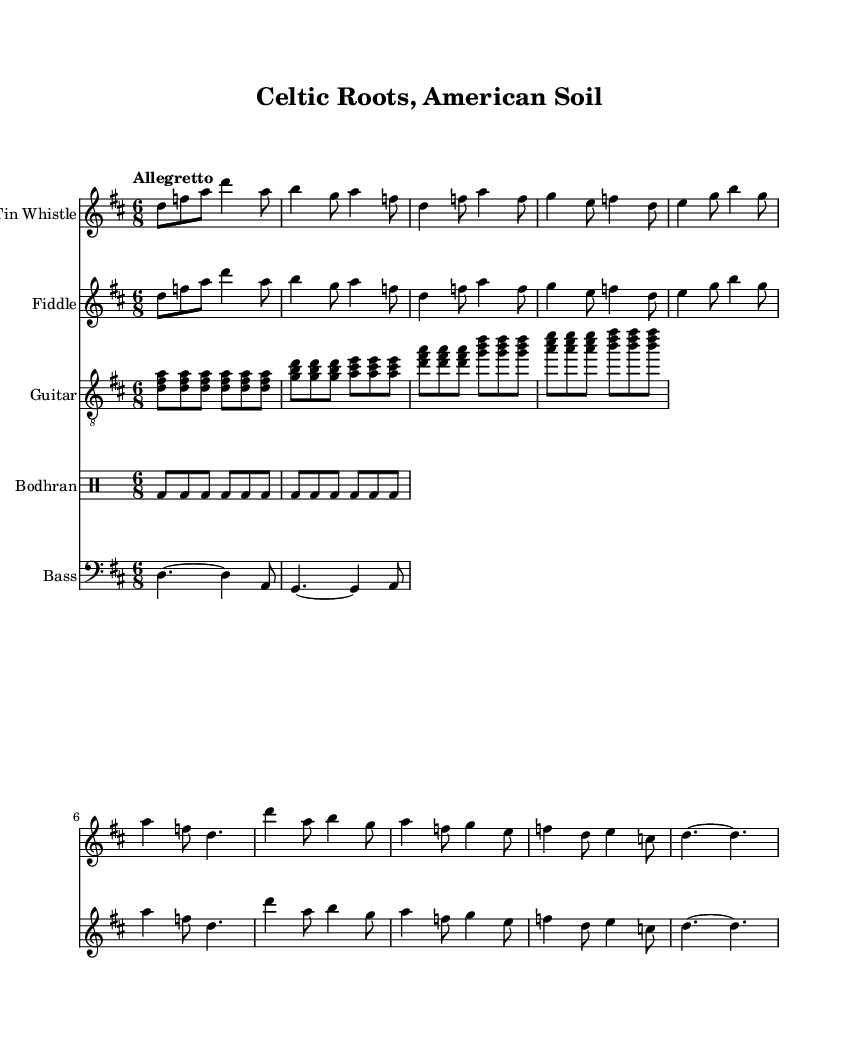What is the key signature of this music? The key signature is D major, which has two sharps (F# and C#). This is derived from the global settings at the beginning of the sheet music where it indicates the key is set to D major.
Answer: D major What is the time signature of the piece? The time signature is 6/8, indicating that there are six beats in a measure and the eighth note gets one beat. This is stated in the global settings within the sheet music, specifying the time signature.
Answer: 6/8 What tempo marking is used for this music? The tempo marking is "Allegretto," which is a moderately fast tempo. This is mentioned at the beginning of the score under global settings.
Answer: Allegretto How many sections are there in the music? There are two main sections identified: Verse and Chorus. The sheet music layout divides the music into these segments clearly, with each labeled accordingly in the annotations.
Answer: 2 What instrument plays the main melody in this piece? The Tin Whistle plays the main melody, as indicated by its arrangement in the score where it is placed at the top of the staff created for that instrument.
Answer: Tin Whistle What is the rhythmic pattern used for the bodhran? The bodhran follows a consistent pattern of bass drum hits (bd) across each measure, creating a steady rhythmic support. This can be seen in the rhythmic notation specific to the drummode section for the bodhran.
Answer: bd What harmony is primarily used in the chorus? The chorus primarily uses the chords D, G, and A. This can be analyzed by looking at the chord symbols notated above the respective measures in the guitar part, which outlines the harmonic structure.
Answer: D, G, A 